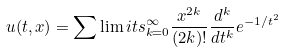Convert formula to latex. <formula><loc_0><loc_0><loc_500><loc_500>u ( t , x ) = \sum \lim i t s _ { k = 0 } ^ { \infty } \frac { x ^ { 2 k } } { ( 2 k ) ! } \frac { d ^ { k } } { d t ^ { k } } e ^ { - 1 / t ^ { 2 } }</formula> 